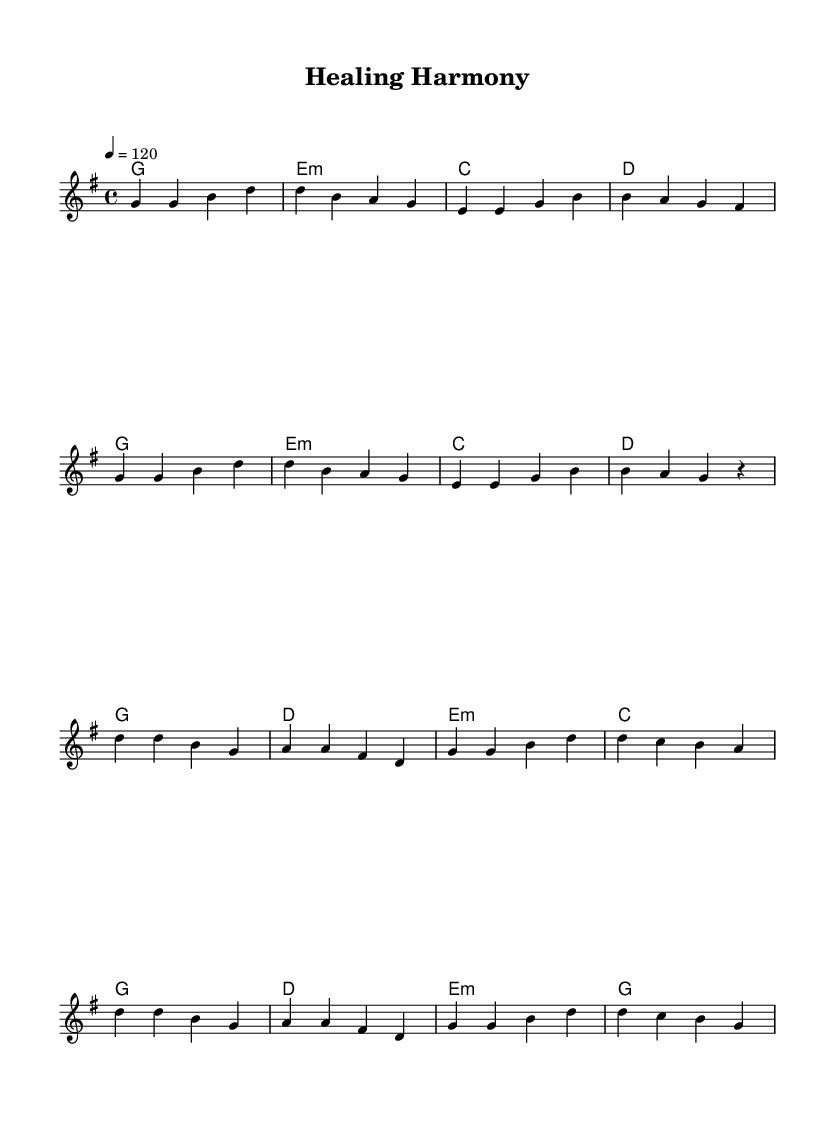What is the key signature of this music? The key signature is indicated by the sharps or flats at the beginning of the staff. In this sheet music, there are no sharps or flats, confirming it is in G major.
Answer: G major What is the time signature of this music? The time signature is found in the beginning of the music, represented as a fraction. In this case, it shows 4/4, meaning there are four beats in a measure.
Answer: 4/4 What is the tempo marking described in this piece? The tempo marking is shown at the beginning of the music, stating how fast the piece should be played. It indicates a speed of 120 beats per minute.
Answer: 120 How many measures are in the verse section? By counting the measures in the melody part labeled as "Verse," you can see there are a total of 8 measures.
Answer: 8 What chord follows the first melody note in the chorus? Looking at the chord progression, the first melody note in the chorus corresponds to the D major chord, as indicated in the harmonies section.
Answer: D What is the primary theme of the piece as reflected in its lyrics and melody? Analyzing the melody and the title "Healing Harmony," this piece celebrates cultural diversity and is likely inspired by the integration of different musical styles, underscoring unity in the medical field.
Answer: Cultural diversity What type of musical fusion does this piece represent? This piece blends Indian and Western musical elements, which can be observed in the rhythm, instrumentation, and melodic styles, exemplifying an Indo-Western pop fusion.
Answer: Indo-Western fusion 